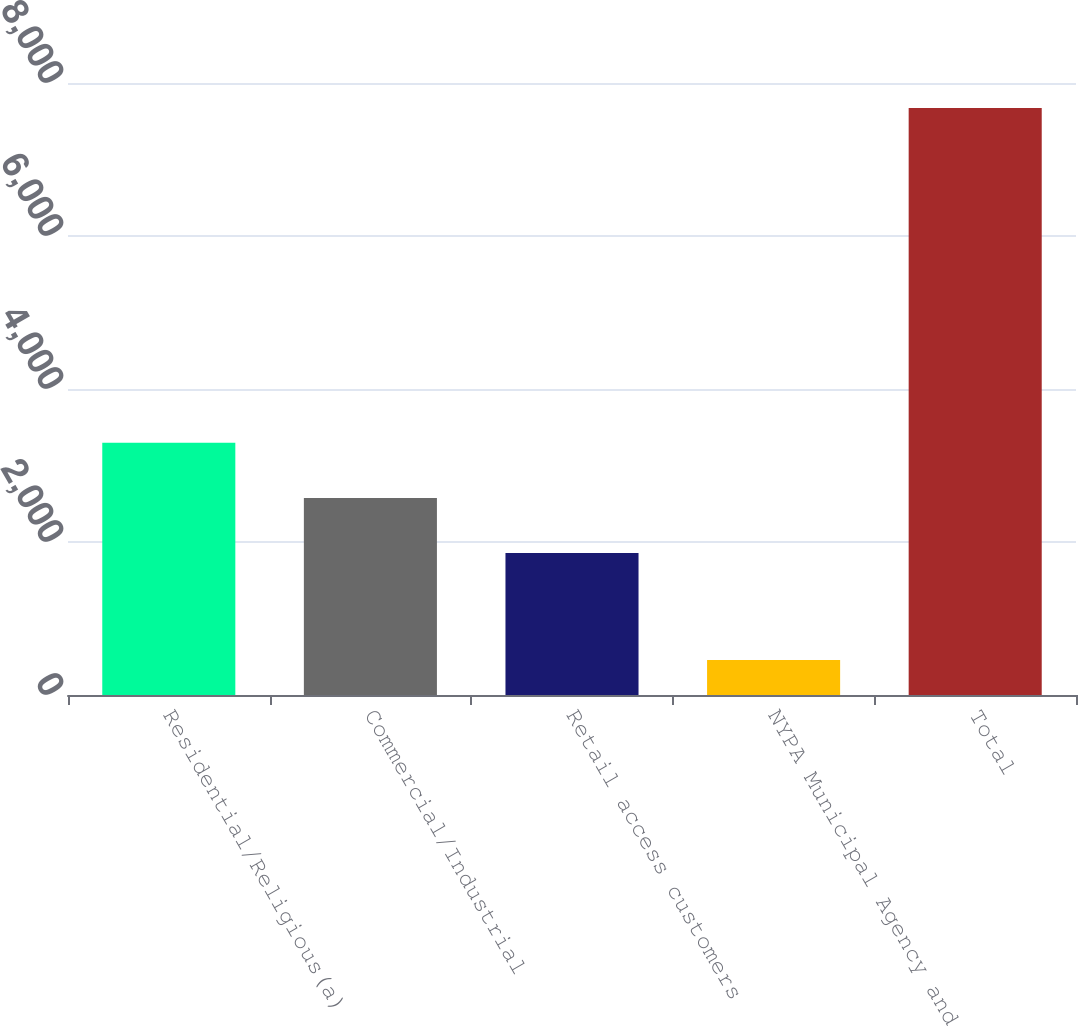<chart> <loc_0><loc_0><loc_500><loc_500><bar_chart><fcel>Residential/Religious(a)<fcel>Commercial/Industrial<fcel>Retail access customers<fcel>NYPA Municipal Agency and<fcel>Total<nl><fcel>3298.4<fcel>2576.7<fcel>1855<fcel>457<fcel>7674<nl></chart> 